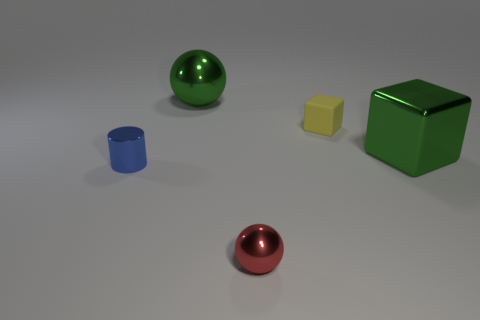How many things are left of the metal cube and in front of the large sphere?
Offer a terse response. 3. Is the number of green things greater than the number of green balls?
Provide a short and direct response. Yes. What is the material of the small yellow object?
Your answer should be compact. Rubber. What number of shiny cylinders are behind the big green thing behind the big metallic cube?
Ensure brevity in your answer.  0. Is the color of the metal block the same as the object behind the small rubber cube?
Your answer should be compact. Yes. What is the color of the metal sphere that is the same size as the blue metallic object?
Offer a terse response. Red. Is there a tiny purple matte object of the same shape as the small blue metal object?
Your response must be concise. No. Is the number of objects less than the number of small rubber cylinders?
Your answer should be very brief. No. The tiny thing that is behind the small blue object is what color?
Offer a very short reply. Yellow. There is a tiny thing behind the large metal thing that is on the right side of the red ball; what is its shape?
Provide a succinct answer. Cube. 